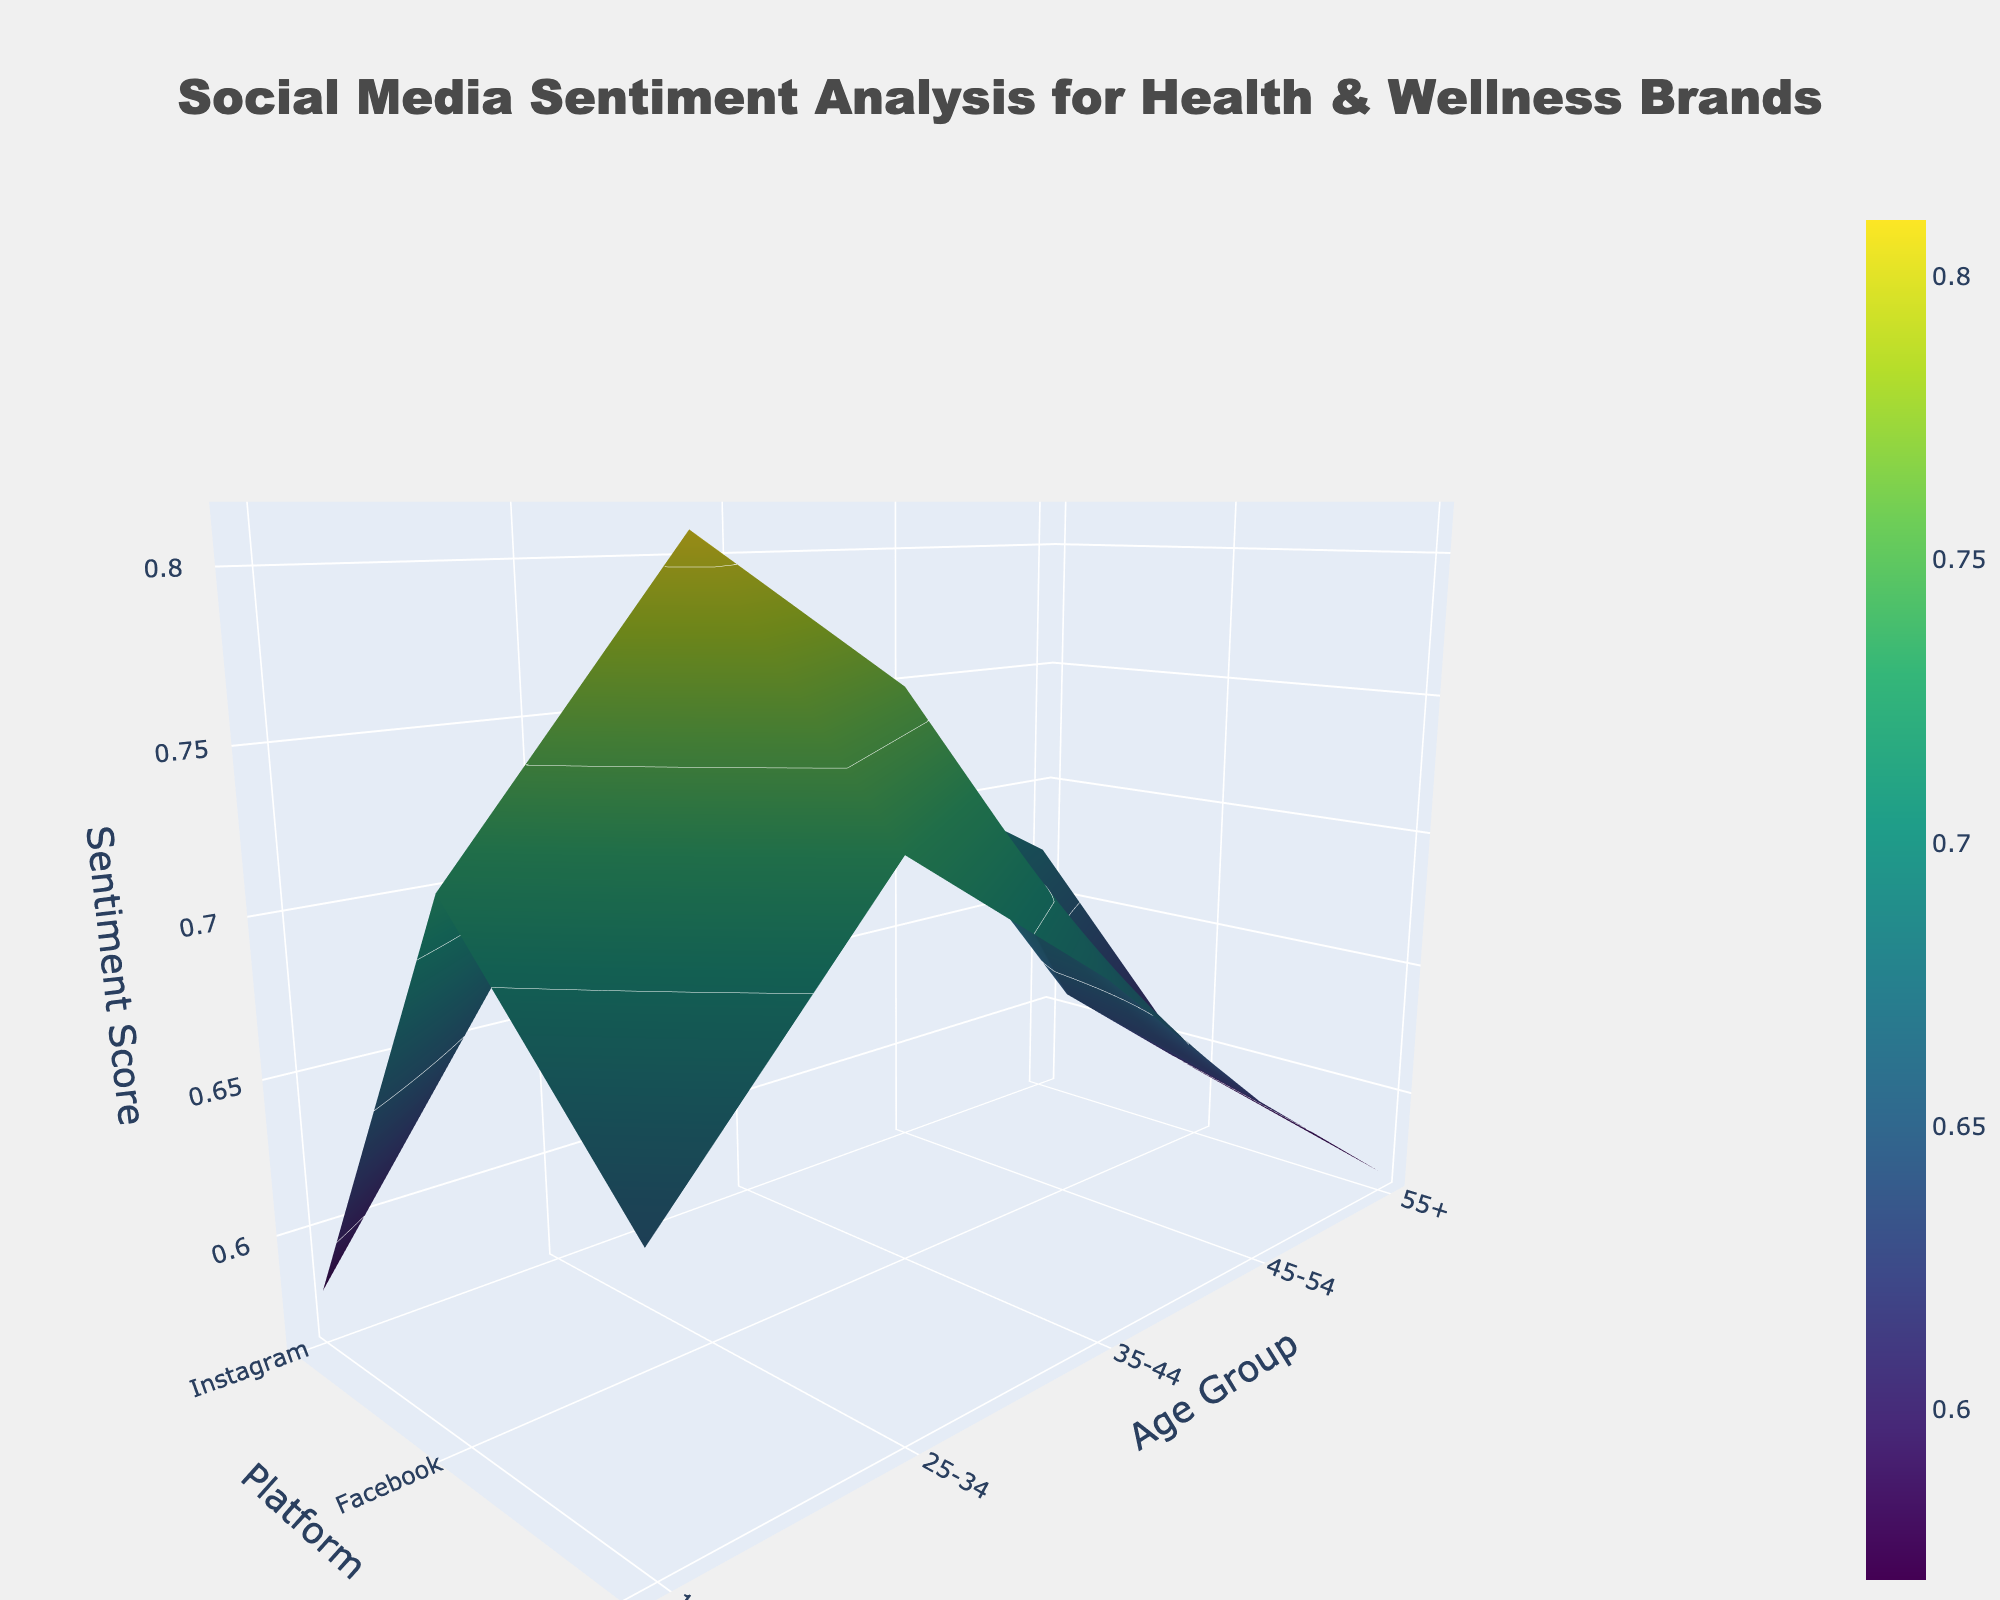What is the title of the plot? The title is displayed at the top of the figure. It reads, "Social Media Sentiment Analysis for Health & Wellness Brands."
Answer: Social Media Sentiment Analysis for Health & Wellness Brands Which platform shows the highest overall sentiment score? By observing the plot, you can compare the height of the surfaces above each platform. The highest surface is above Instagram.
Answer: Instagram Which age group has the most positive sentiment for Twitter? Look at the sentiment values on the z-axis for each age group along the y-axis for the Twitter platform. The peak for Twitter appears for the 25-34 age group.
Answer: 25-34 What is the general trend of sentiment scores on Instagram across different age groups? Observe the surface plot for the Instagram platform from left to right. The values show a decrease from younger to older age groups.
Answer: Decreasing Between the age groups 35-44 and 45-54, which one shows a higher sentiment score on Facebook? Locate the sentiment scores on the z-axis for these two age groups along the y-axis for Facebook. The 45-54 age group has a higher score compared to 35-44.
Answer: 45-54 What is the difference in sentiment score for the 25-34 age group between Instagram and Facebook? Find the z-axis values for the 25-34 age group for both Instagram and Facebook. Subtract the Facebook value (0.69) from the Instagram value (0.81).
Answer: 0.12 Is there any age group where the sentiment score for Twitter is higher than for Facebook? Compare each age group’s sentiment score for Twitter and Facebook. For every age group, Facebook has a higher sentiment score than Twitter.
Answer: No Which platform exhibits the most uniform sentiment scores across all age groups? Look at the smoothness and uniform height of surfaces for each platform across the y-axis. Facebook appears to have the most uniform sentiment scores.
Answer: Facebook What can be inferred about the sentiment towards health and wellness brands among the older age group (55+) across different platforms? Observe the sentiment scores for the 55+ age group across Instagram, Facebook, and Twitter. Scores are generally lower across all platforms, with Facebook having the highest score among them.
Answer: Lower sentiment scores, Facebook highest Which age group-platform combination shows the lowest sentiment score? Identify the lowest point on the z-axis across all age groups and platforms. The lowest sentiment score is for the 55+ age group on Twitter.
Answer: 55+ and Twitter 